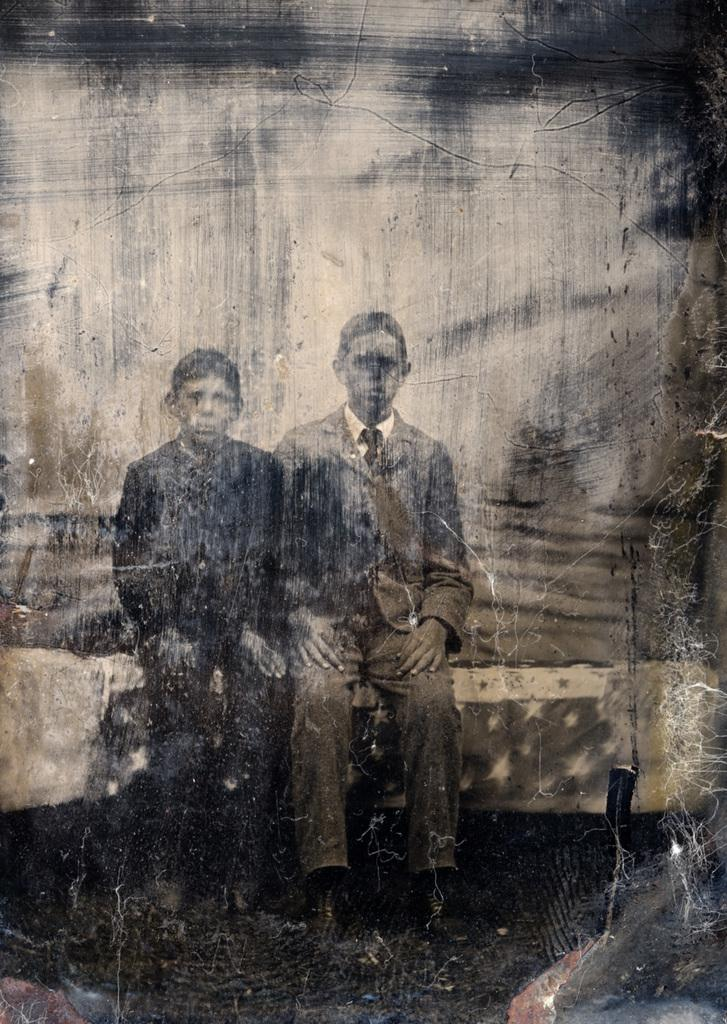What is the main subject of the image? The main subject of the image is a photo. What can be seen in the photo? The photo contains two persons. What are the two persons doing in the photo? The two persons are sitting on some object. What type of bird can be seen flying in the direction of the photo? There is no bird present in the image, and therefore no such activity can be observed. What type of agricultural equipment is visible in the photo? There is no agricultural equipment present in the photo; it only contains two persons sitting on some object. 